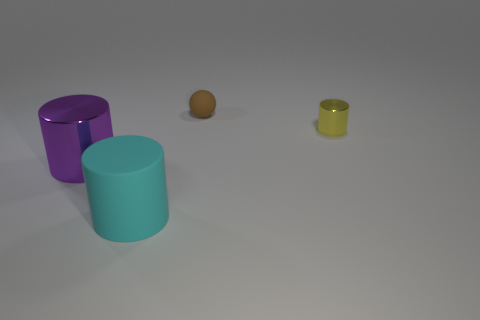How many objects are on the right side of the image compared to the left? On the right side of the image, there are two objects, a purple cylinder, and a small yellow cylinder. On the left, there's a single teal cylinder, so there are more objects on the right. 